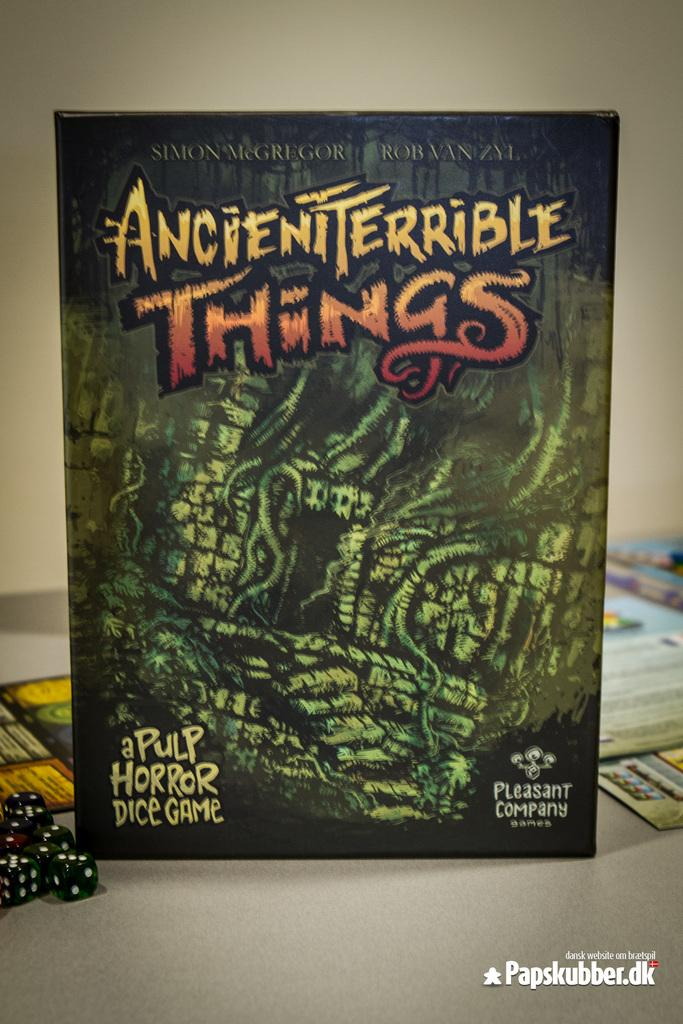<image>
Offer a succinct explanation of the picture presented. A board game is laid on the table while the box stands up to identify the game as AncientTerrible Things. 